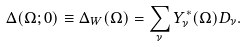<formula> <loc_0><loc_0><loc_500><loc_500>\Delta ( \Omega ; 0 ) \equiv \Delta _ { W } ( \Omega ) = \sum _ { \nu } Y _ { \nu } ^ { \ast } ( \Omega ) D _ { \nu } .</formula> 